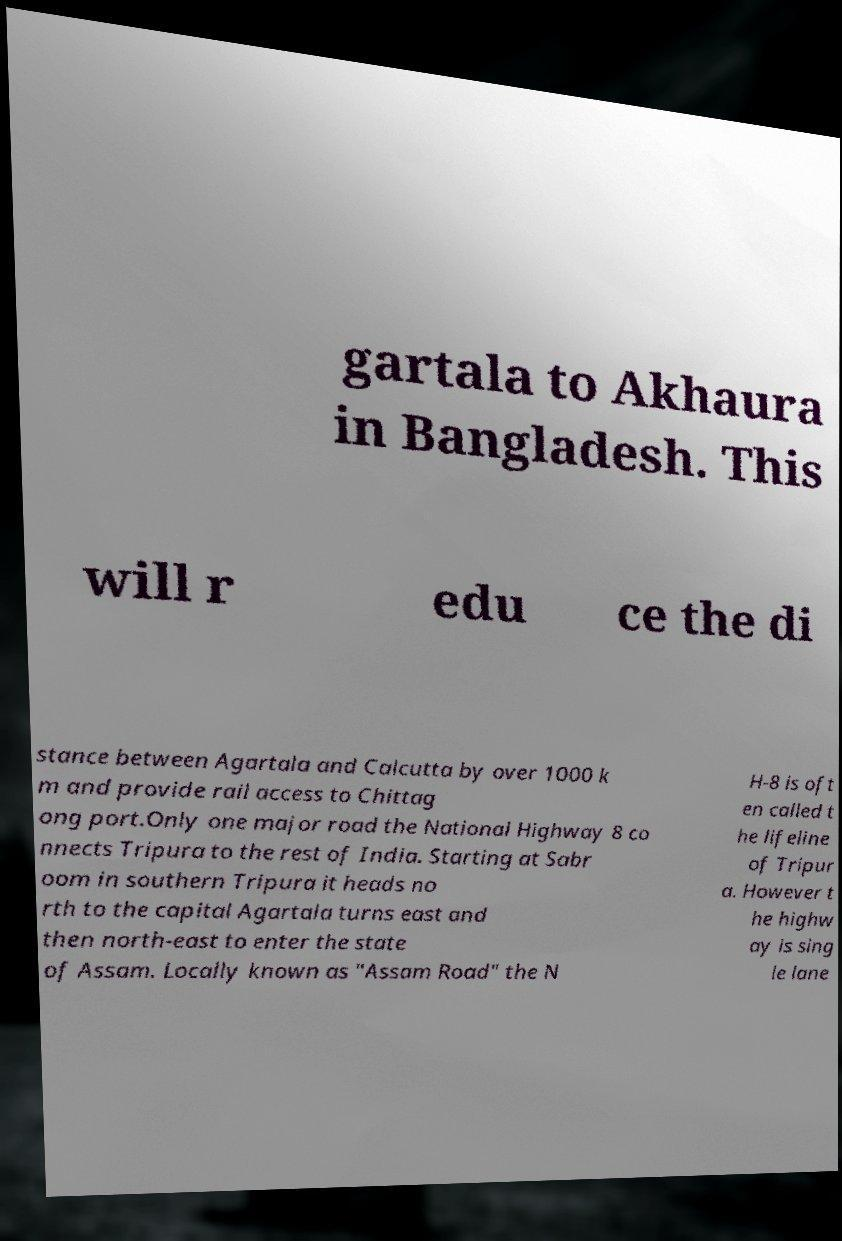Please read and relay the text visible in this image. What does it say? gartala to Akhaura in Bangladesh. This will r edu ce the di stance between Agartala and Calcutta by over 1000 k m and provide rail access to Chittag ong port.Only one major road the National Highway 8 co nnects Tripura to the rest of India. Starting at Sabr oom in southern Tripura it heads no rth to the capital Agartala turns east and then north-east to enter the state of Assam. Locally known as "Assam Road" the N H-8 is oft en called t he lifeline of Tripur a. However t he highw ay is sing le lane 